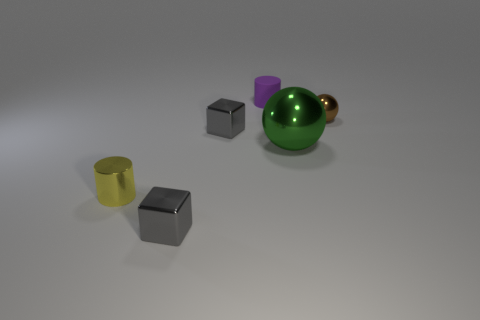Subtract all gray cubes. How many were subtracted if there are1gray cubes left? 1 Add 3 tiny metallic cubes. How many objects exist? 9 Subtract all spheres. How many objects are left? 4 Subtract 0 brown blocks. How many objects are left? 6 Subtract all tiny shiny things. Subtract all tiny cylinders. How many objects are left? 0 Add 5 small rubber cylinders. How many small rubber cylinders are left? 6 Add 3 small matte cylinders. How many small matte cylinders exist? 4 